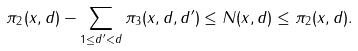Convert formula to latex. <formula><loc_0><loc_0><loc_500><loc_500>\pi _ { 2 } ( x , d ) - \sum _ { 1 \leq d ^ { \prime } < d } \pi _ { 3 } ( x , d , d ^ { \prime } ) \leq N ( x , d ) \leq \pi _ { 2 } ( x , d ) .</formula> 